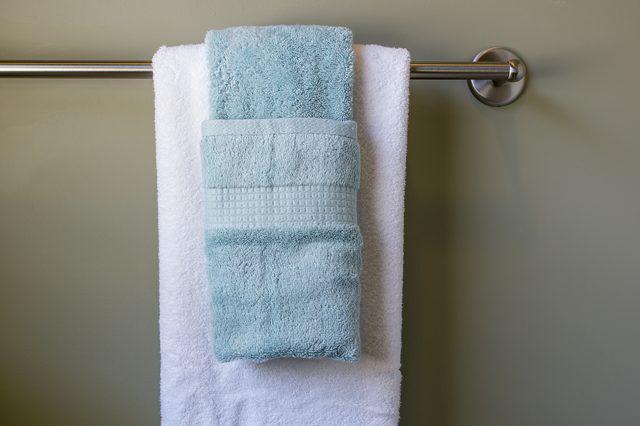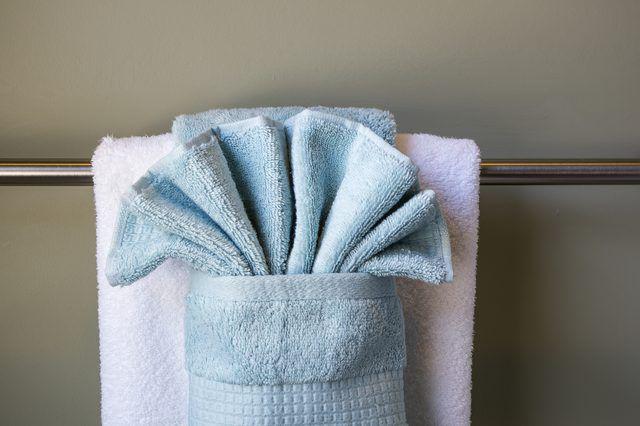The first image is the image on the left, the second image is the image on the right. Given the left and right images, does the statement "One of the blue towels is folded into a fan shape on the top part." hold true? Answer yes or no. Yes. The first image is the image on the left, the second image is the image on the right. Examine the images to the left and right. Is the description "There are blue towels." accurate? Answer yes or no. Yes. 